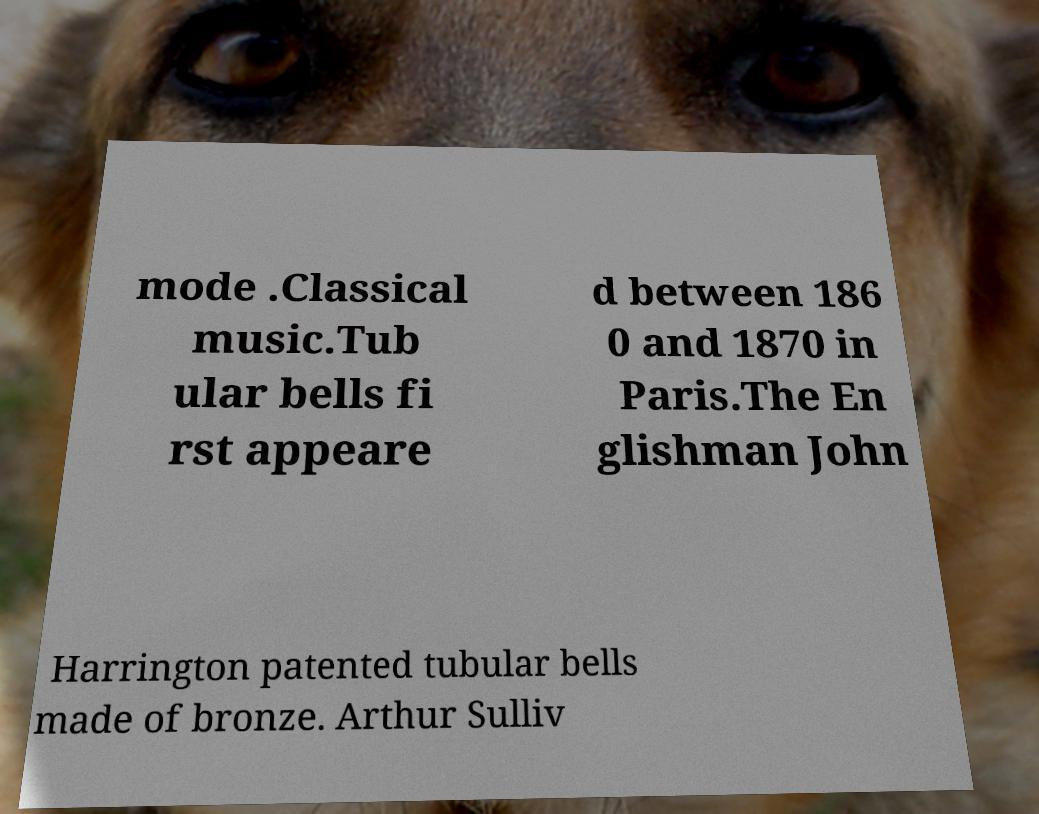What messages or text are displayed in this image? I need them in a readable, typed format. mode .Classical music.Tub ular bells fi rst appeare d between 186 0 and 1870 in Paris.The En glishman John Harrington patented tubular bells made of bronze. Arthur Sulliv 